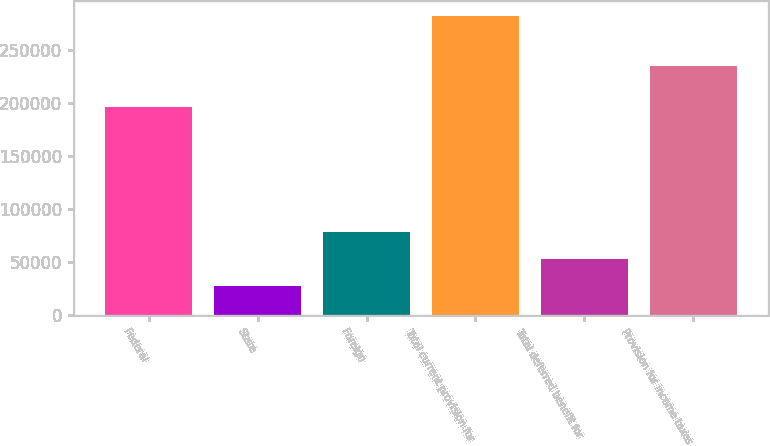<chart> <loc_0><loc_0><loc_500><loc_500><bar_chart><fcel>Federal<fcel>State<fcel>Foreign<fcel>Total current provision for<fcel>Total deferred benefit for<fcel>Provision for income taxes<nl><fcel>196825<fcel>27149<fcel>78138.6<fcel>282097<fcel>52643.8<fcel>235560<nl></chart> 